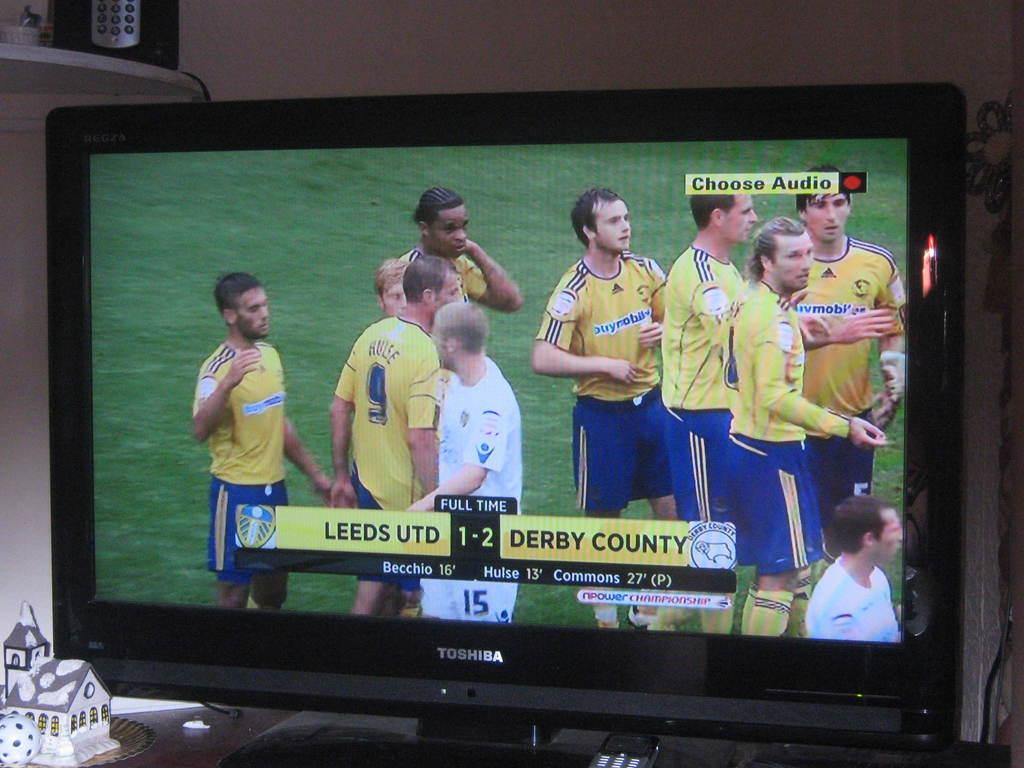<image>
Offer a succinct explanation of the picture presented. A tv showing a match between Leeds UTD and Derby County. 